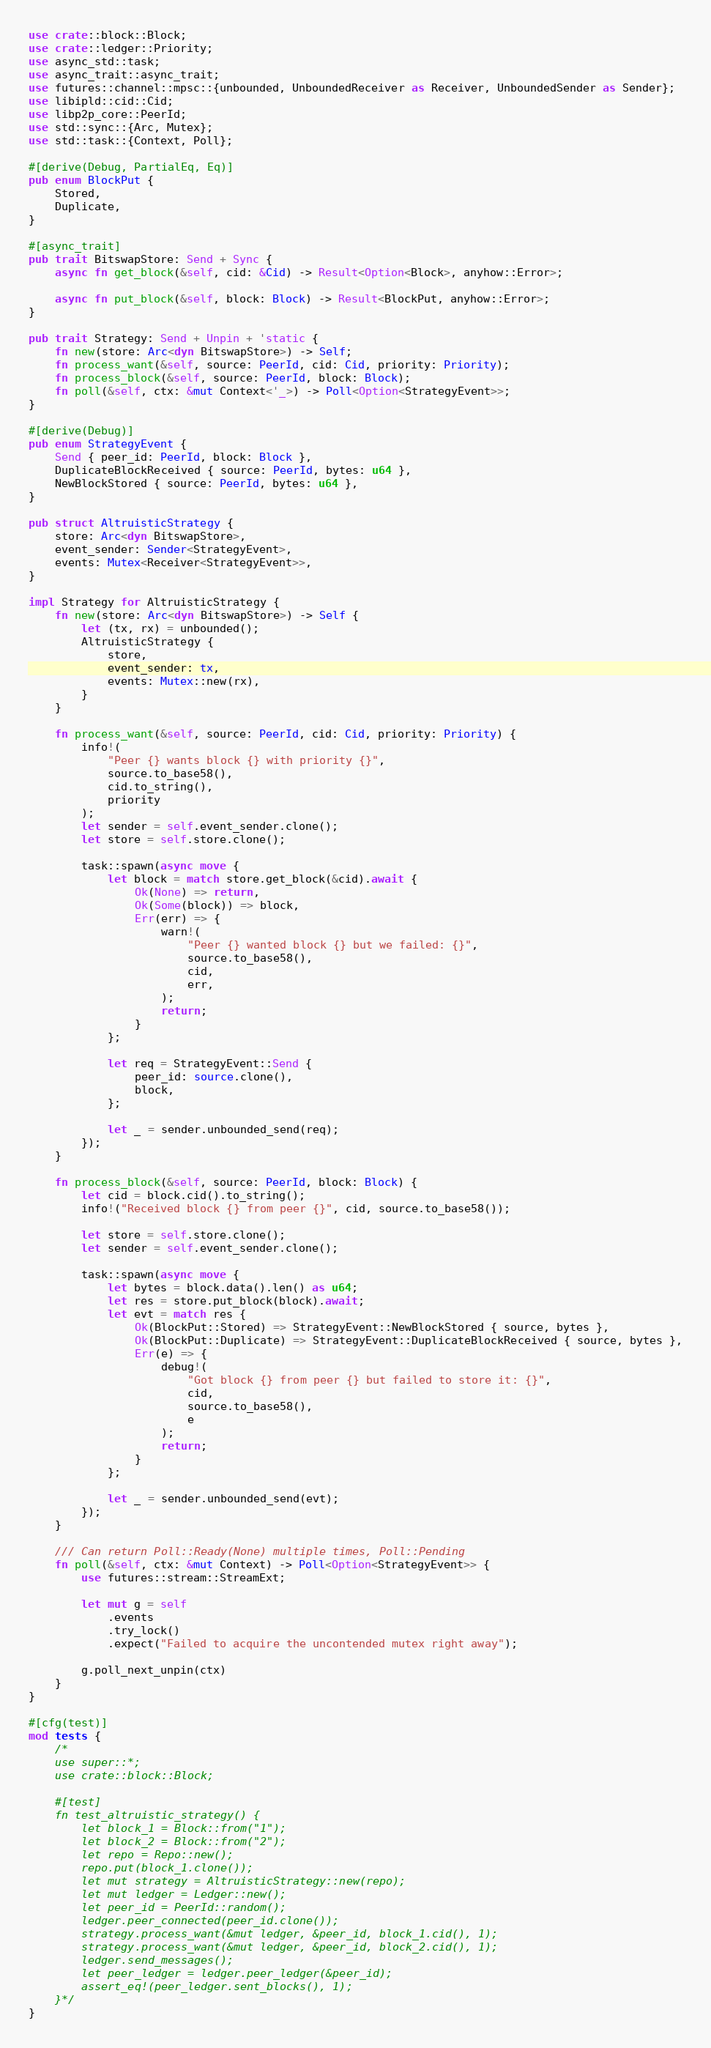<code> <loc_0><loc_0><loc_500><loc_500><_Rust_>use crate::block::Block;
use crate::ledger::Priority;
use async_std::task;
use async_trait::async_trait;
use futures::channel::mpsc::{unbounded, UnboundedReceiver as Receiver, UnboundedSender as Sender};
use libipld::cid::Cid;
use libp2p_core::PeerId;
use std::sync::{Arc, Mutex};
use std::task::{Context, Poll};

#[derive(Debug, PartialEq, Eq)]
pub enum BlockPut {
    Stored,
    Duplicate,
}

#[async_trait]
pub trait BitswapStore: Send + Sync {
    async fn get_block(&self, cid: &Cid) -> Result<Option<Block>, anyhow::Error>;

    async fn put_block(&self, block: Block) -> Result<BlockPut, anyhow::Error>;
}

pub trait Strategy: Send + Unpin + 'static {
    fn new(store: Arc<dyn BitswapStore>) -> Self;
    fn process_want(&self, source: PeerId, cid: Cid, priority: Priority);
    fn process_block(&self, source: PeerId, block: Block);
    fn poll(&self, ctx: &mut Context<'_>) -> Poll<Option<StrategyEvent>>;
}

#[derive(Debug)]
pub enum StrategyEvent {
    Send { peer_id: PeerId, block: Block },
    DuplicateBlockReceived { source: PeerId, bytes: u64 },
    NewBlockStored { source: PeerId, bytes: u64 },
}

pub struct AltruisticStrategy {
    store: Arc<dyn BitswapStore>,
    event_sender: Sender<StrategyEvent>,
    events: Mutex<Receiver<StrategyEvent>>,
}

impl Strategy for AltruisticStrategy {
    fn new(store: Arc<dyn BitswapStore>) -> Self {
        let (tx, rx) = unbounded();
        AltruisticStrategy {
            store,
            event_sender: tx,
            events: Mutex::new(rx),
        }
    }

    fn process_want(&self, source: PeerId, cid: Cid, priority: Priority) {
        info!(
            "Peer {} wants block {} with priority {}",
            source.to_base58(),
            cid.to_string(),
            priority
        );
        let sender = self.event_sender.clone();
        let store = self.store.clone();

        task::spawn(async move {
            let block = match store.get_block(&cid).await {
                Ok(None) => return,
                Ok(Some(block)) => block,
                Err(err) => {
                    warn!(
                        "Peer {} wanted block {} but we failed: {}",
                        source.to_base58(),
                        cid,
                        err,
                    );
                    return;
                }
            };

            let req = StrategyEvent::Send {
                peer_id: source.clone(),
                block,
            };

            let _ = sender.unbounded_send(req);
        });
    }

    fn process_block(&self, source: PeerId, block: Block) {
        let cid = block.cid().to_string();
        info!("Received block {} from peer {}", cid, source.to_base58());

        let store = self.store.clone();
        let sender = self.event_sender.clone();

        task::spawn(async move {
            let bytes = block.data().len() as u64;
            let res = store.put_block(block).await;
            let evt = match res {
                Ok(BlockPut::Stored) => StrategyEvent::NewBlockStored { source, bytes },
                Ok(BlockPut::Duplicate) => StrategyEvent::DuplicateBlockReceived { source, bytes },
                Err(e) => {
                    debug!(
                        "Got block {} from peer {} but failed to store it: {}",
                        cid,
                        source.to_base58(),
                        e
                    );
                    return;
                }
            };

            let _ = sender.unbounded_send(evt);
        });
    }

    /// Can return Poll::Ready(None) multiple times, Poll::Pending
    fn poll(&self, ctx: &mut Context) -> Poll<Option<StrategyEvent>> {
        use futures::stream::StreamExt;

        let mut g = self
            .events
            .try_lock()
            .expect("Failed to acquire the uncontended mutex right away");

        g.poll_next_unpin(ctx)
    }
}

#[cfg(test)]
mod tests {
    /*
    use super::*;
    use crate::block::Block;

    #[test]
    fn test_altruistic_strategy() {
        let block_1 = Block::from("1");
        let block_2 = Block::from("2");
        let repo = Repo::new();
        repo.put(block_1.clone());
        let mut strategy = AltruisticStrategy::new(repo);
        let mut ledger = Ledger::new();
        let peer_id = PeerId::random();
        ledger.peer_connected(peer_id.clone());
        strategy.process_want(&mut ledger, &peer_id, block_1.cid(), 1);
        strategy.process_want(&mut ledger, &peer_id, block_2.cid(), 1);
        ledger.send_messages();
        let peer_ledger = ledger.peer_ledger(&peer_id);
        assert_eq!(peer_ledger.sent_blocks(), 1);
    }*/
}
</code> 